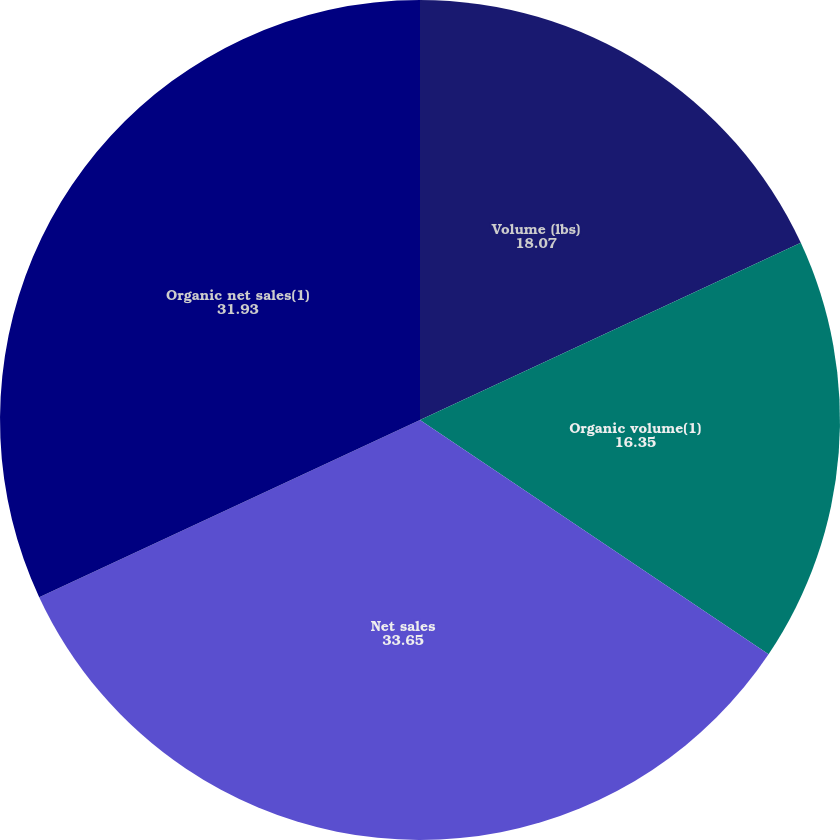Convert chart to OTSL. <chart><loc_0><loc_0><loc_500><loc_500><pie_chart><fcel>Volume (lbs)<fcel>Organic volume(1)<fcel>Net sales<fcel>Organic net sales(1)<nl><fcel>18.07%<fcel>16.35%<fcel>33.65%<fcel>31.93%<nl></chart> 